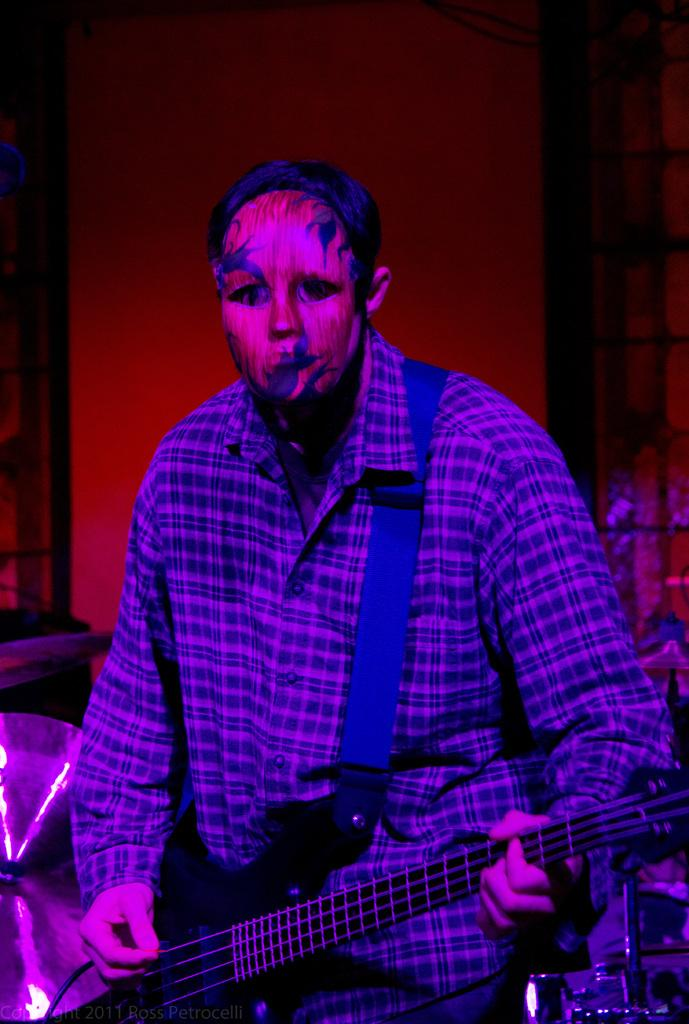Who is present in the image? There is a person in the image. What is the person wearing? The person is wearing a mask. What is the person holding in the image? The person is holding a guitar. What type of division can be seen in the image? There is no division present in the image; it features a person wearing a mask and holding a guitar. How many fans are visible in the image? There are no fans present in the image. 